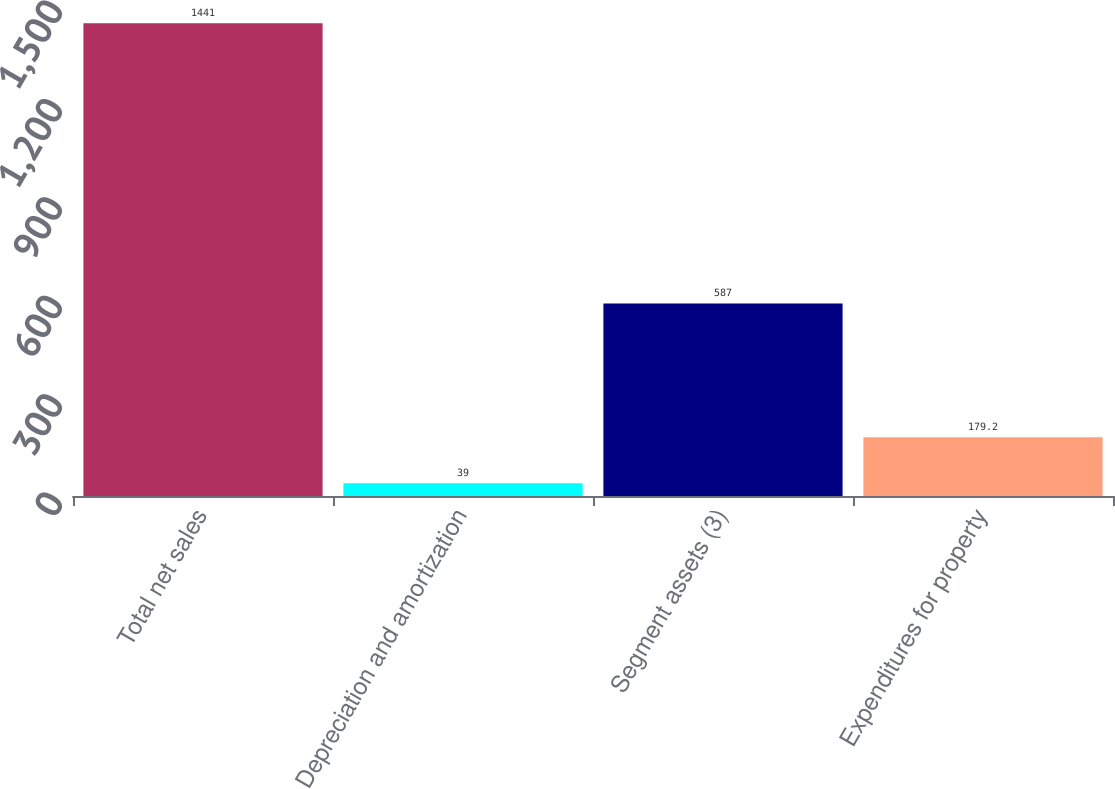Convert chart. <chart><loc_0><loc_0><loc_500><loc_500><bar_chart><fcel>Total net sales<fcel>Depreciation and amortization<fcel>Segment assets (3)<fcel>Expenditures for property<nl><fcel>1441<fcel>39<fcel>587<fcel>179.2<nl></chart> 